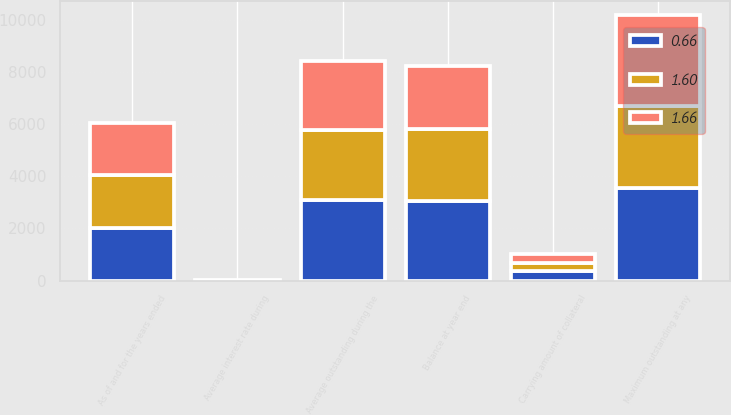Convert chart. <chart><loc_0><loc_0><loc_500><loc_500><stacked_bar_chart><ecel><fcel>As of and for the years ended<fcel>Balance at year end<fcel>Average outstanding during the<fcel>Maximum outstanding at any<fcel>Average interest rate during<fcel>Carrying amount of collateral<nl><fcel>1.66<fcel>2018<fcel>2404.5<fcel>2653.6<fcel>3510.1<fcel>2.05<fcel>342.3<nl><fcel>1.6<fcel>2017<fcel>2774.4<fcel>2677.5<fcel>3130.8<fcel>1.17<fcel>307.7<nl><fcel>0.66<fcel>2016<fcel>3061.1<fcel>3093.7<fcel>3562.5<fcel>0.62<fcel>350.2<nl></chart> 